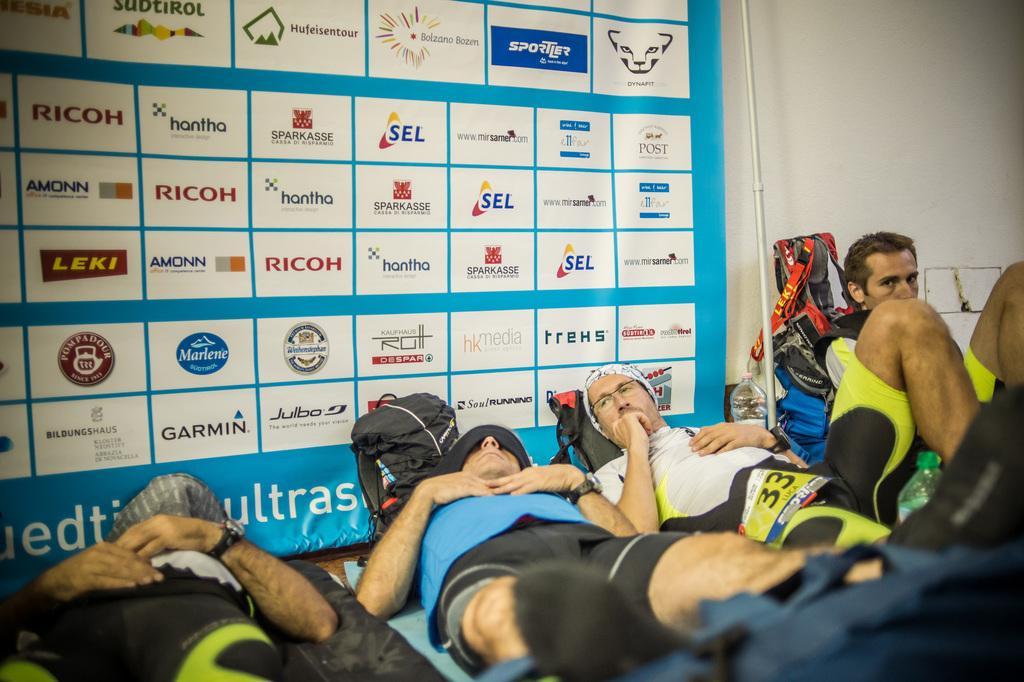In one or two sentences, can you explain what this image depicts? In this image there are a few people lying and sitting on the floor, there are few bags, a rod and a bottle. In the background there is a banner with some images and text on it. 